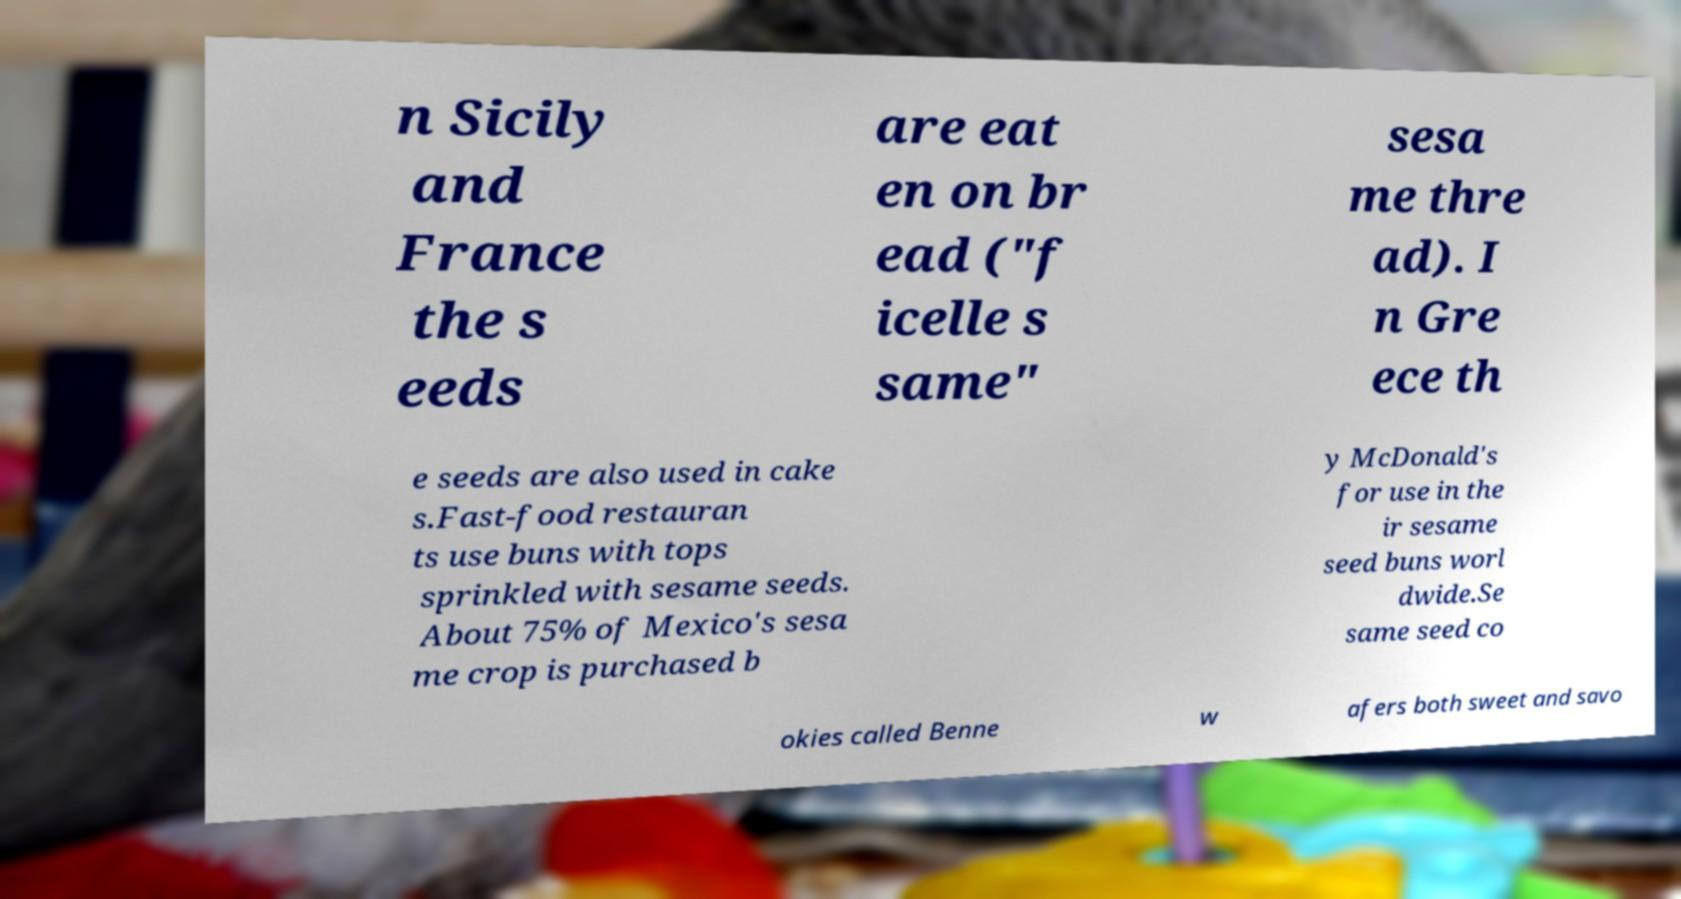For documentation purposes, I need the text within this image transcribed. Could you provide that? n Sicily and France the s eeds are eat en on br ead ("f icelle s same" sesa me thre ad). I n Gre ece th e seeds are also used in cake s.Fast-food restauran ts use buns with tops sprinkled with sesame seeds. About 75% of Mexico's sesa me crop is purchased b y McDonald's for use in the ir sesame seed buns worl dwide.Se same seed co okies called Benne w afers both sweet and savo 